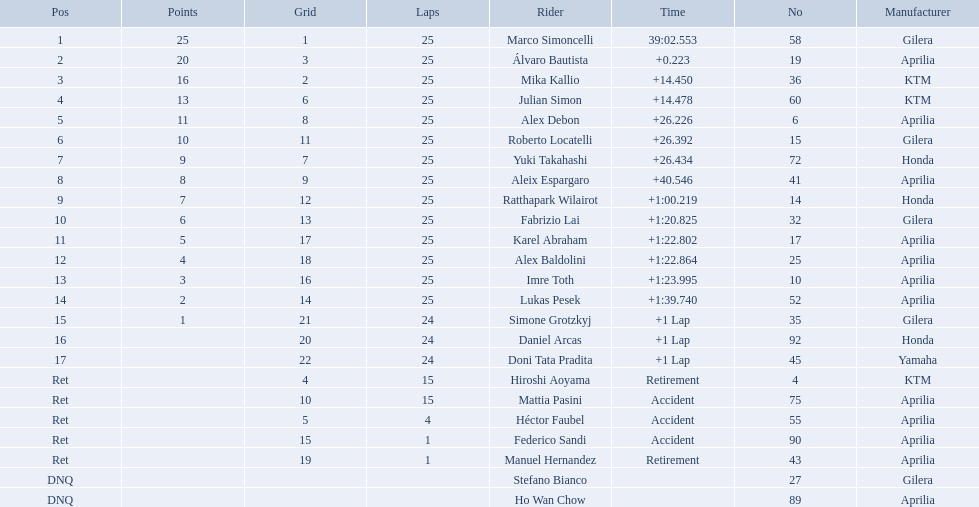What player number is marked #1 for the australian motorcycle grand prix? 58. Who is the rider that represents the #58 in the australian motorcycle grand prix? Marco Simoncelli. 